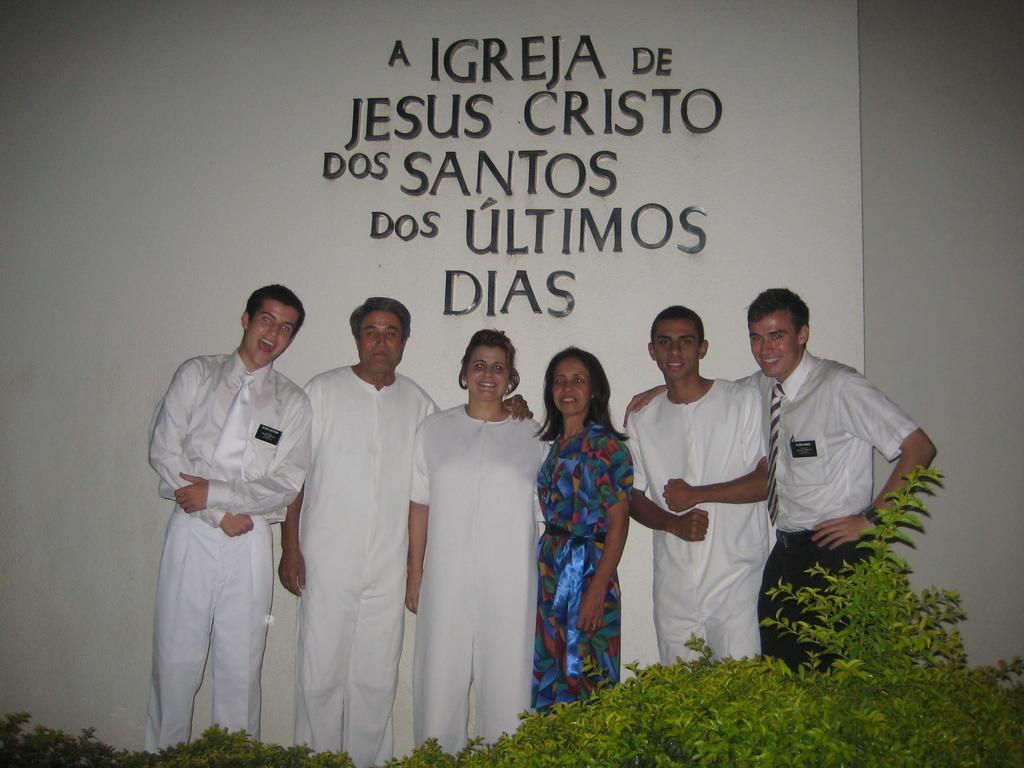Describe this image in one or two sentences. In this picture we can see a group of people standing and smiling, plants and in the background we can see some text on the wall. 